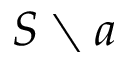Convert formula to latex. <formula><loc_0><loc_0><loc_500><loc_500>S \ a</formula> 